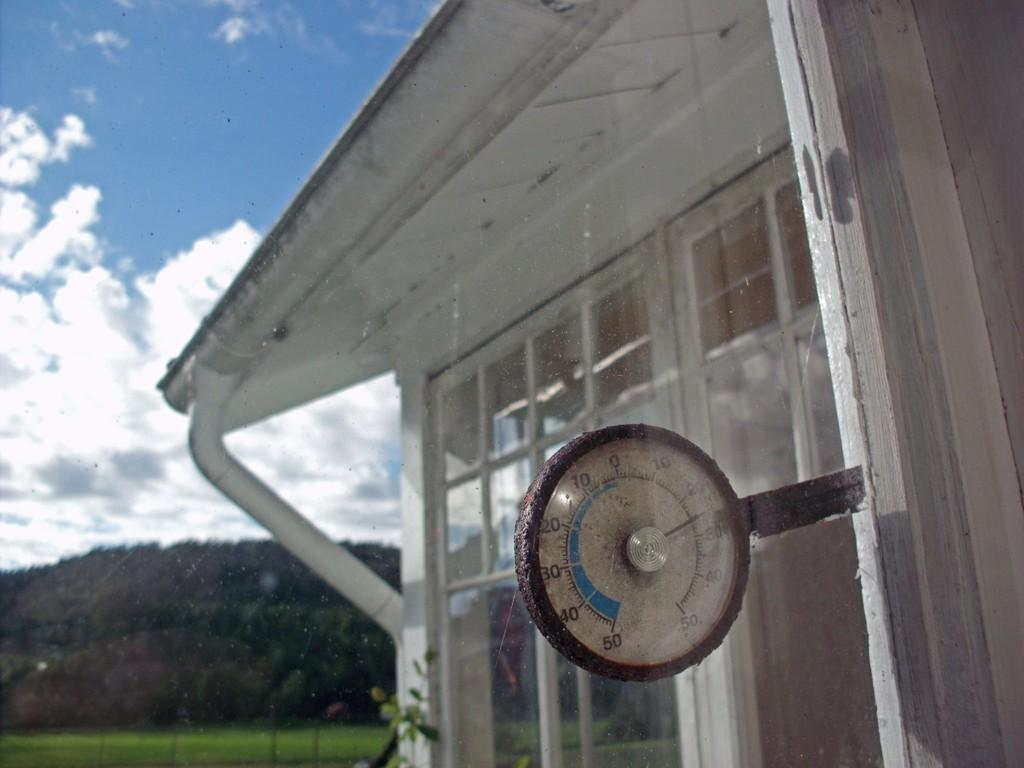What type of structure is visible in the image? There is a building in the image. What object is located in the middle of the image? There is a compass in the middle of the image. What type of vegetation is at the bottom of the image? There are trees at the bottom of the image. What is visible at the top of the image? The sky is visible at the top of the image. How many songs are being sung by the slaves in the image? There are no slaves or songs present in the image; it features a building, a compass, trees, and the sky. What type of fowl can be seen in the image? There is no fowl present in the image. 